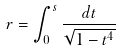<formula> <loc_0><loc_0><loc_500><loc_500>r = \int _ { 0 } ^ { s } \frac { d t } { \sqrt { 1 - t ^ { 4 } } }</formula> 